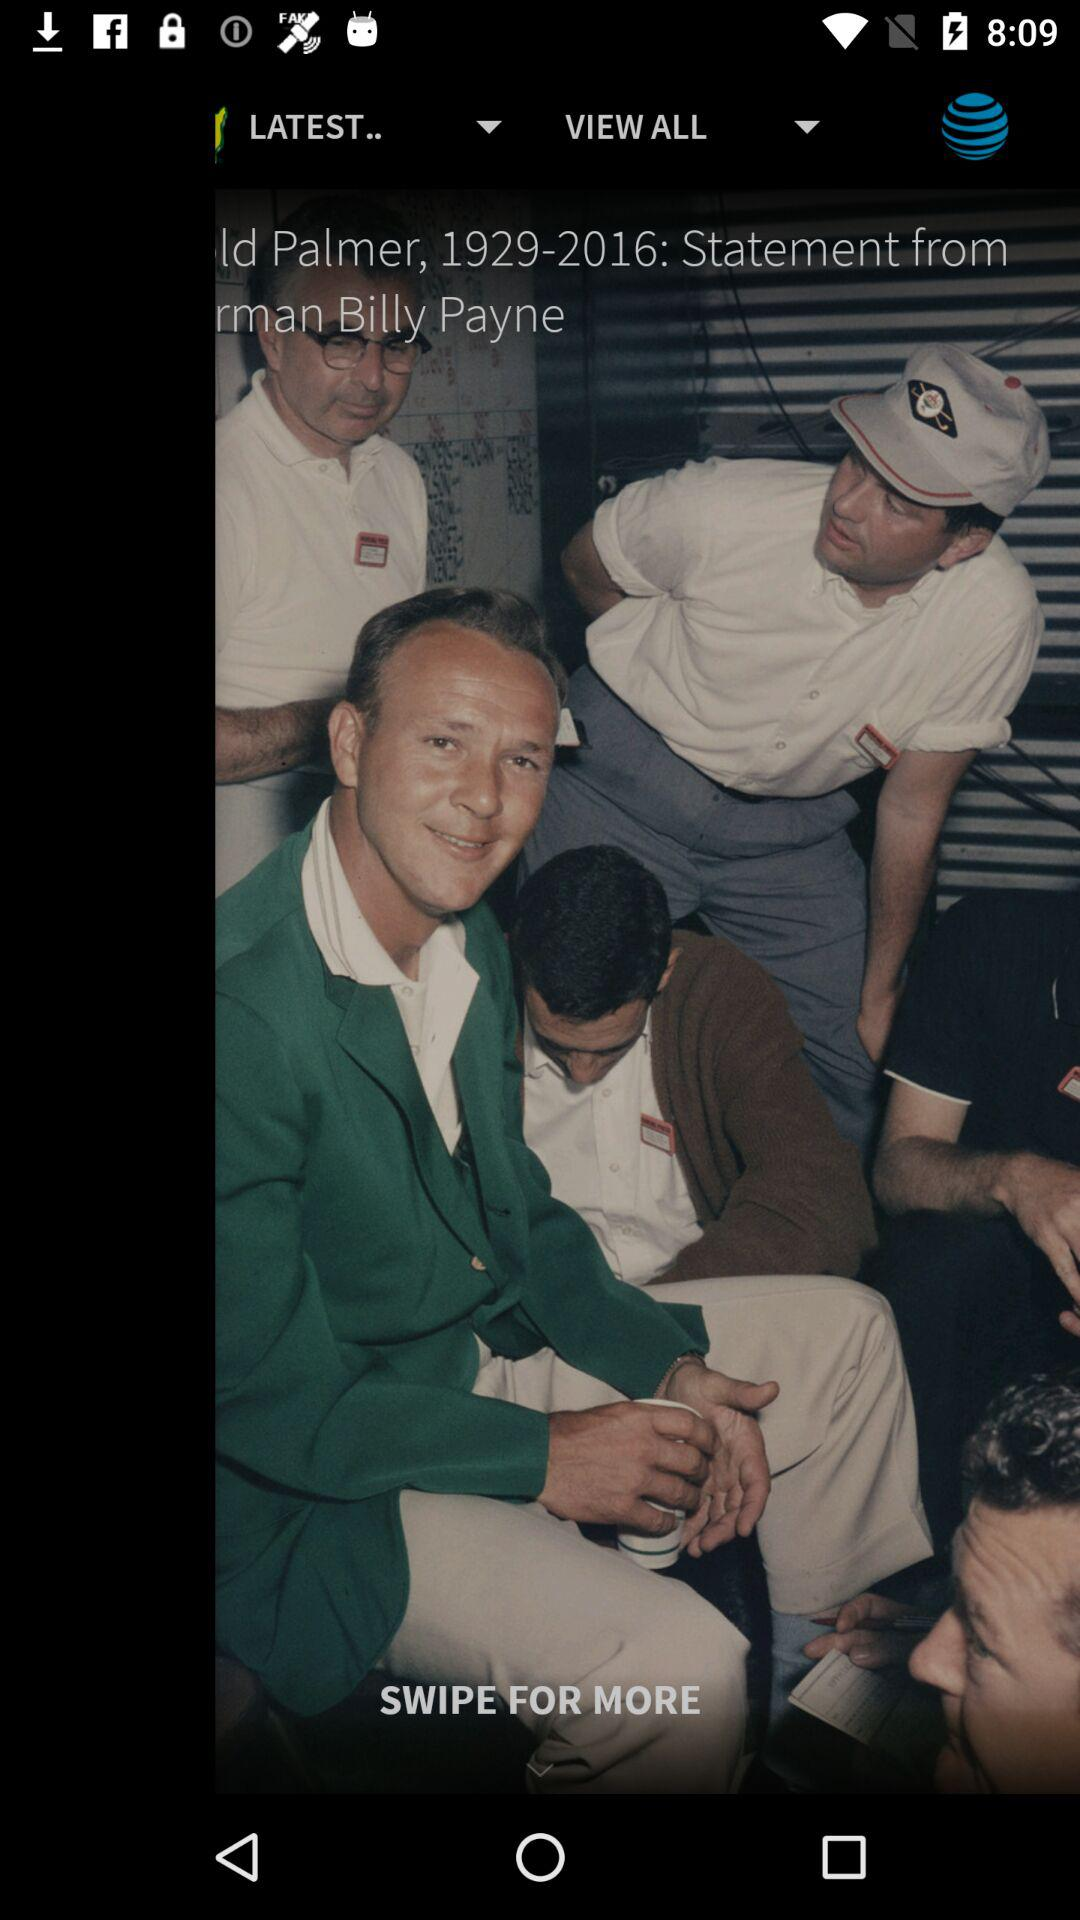What is the hole number? The hole number is 18. 